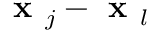<formula> <loc_0><loc_0><loc_500><loc_500>x _ { j } - x _ { l }</formula> 